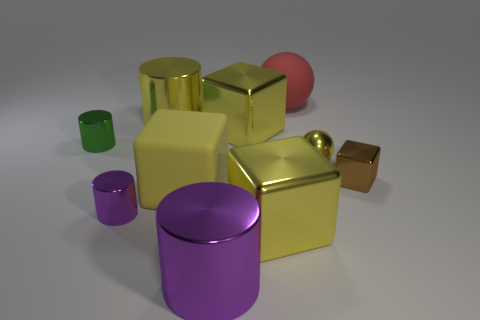There is a small cube that is made of the same material as the tiny ball; what color is it?
Your answer should be very brief. Brown. How many other tiny purple things have the same material as the tiny purple object?
Provide a short and direct response. 0. There is a large yellow rubber object; how many small things are on the left side of it?
Your answer should be very brief. 2. Do the yellow block behind the green object and the sphere right of the red thing have the same material?
Your answer should be very brief. Yes. Is the number of small metal objects on the left side of the yellow ball greater than the number of small metal blocks that are on the left side of the tiny green cylinder?
Ensure brevity in your answer.  Yes. The small object that is both on the right side of the big purple object and behind the tiny metallic cube is made of what material?
Provide a short and direct response. Metal. Do the brown thing and the tiny cylinder that is behind the tiny yellow thing have the same material?
Your answer should be compact. Yes. How many things are either large yellow matte things or large cubes in front of the tiny brown shiny cube?
Make the answer very short. 2. Is the size of the shiny cube to the right of the red ball the same as the purple object that is behind the large purple thing?
Provide a short and direct response. Yes. How many other objects are there of the same color as the rubber block?
Your response must be concise. 4. 